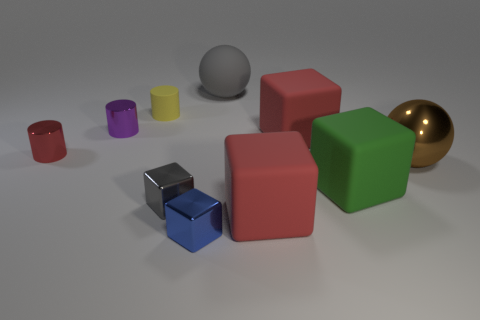Subtract all purple blocks. Subtract all purple cylinders. How many blocks are left? 5 Subtract all cylinders. How many objects are left? 7 Subtract 1 gray spheres. How many objects are left? 9 Subtract all tiny purple objects. Subtract all small purple cylinders. How many objects are left? 8 Add 5 purple objects. How many purple objects are left? 6 Add 7 metal cylinders. How many metal cylinders exist? 9 